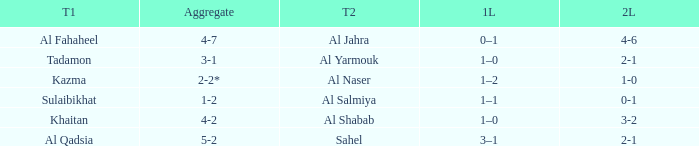What is the 1st leg of the Al Fahaheel Team 1? 0–1. 